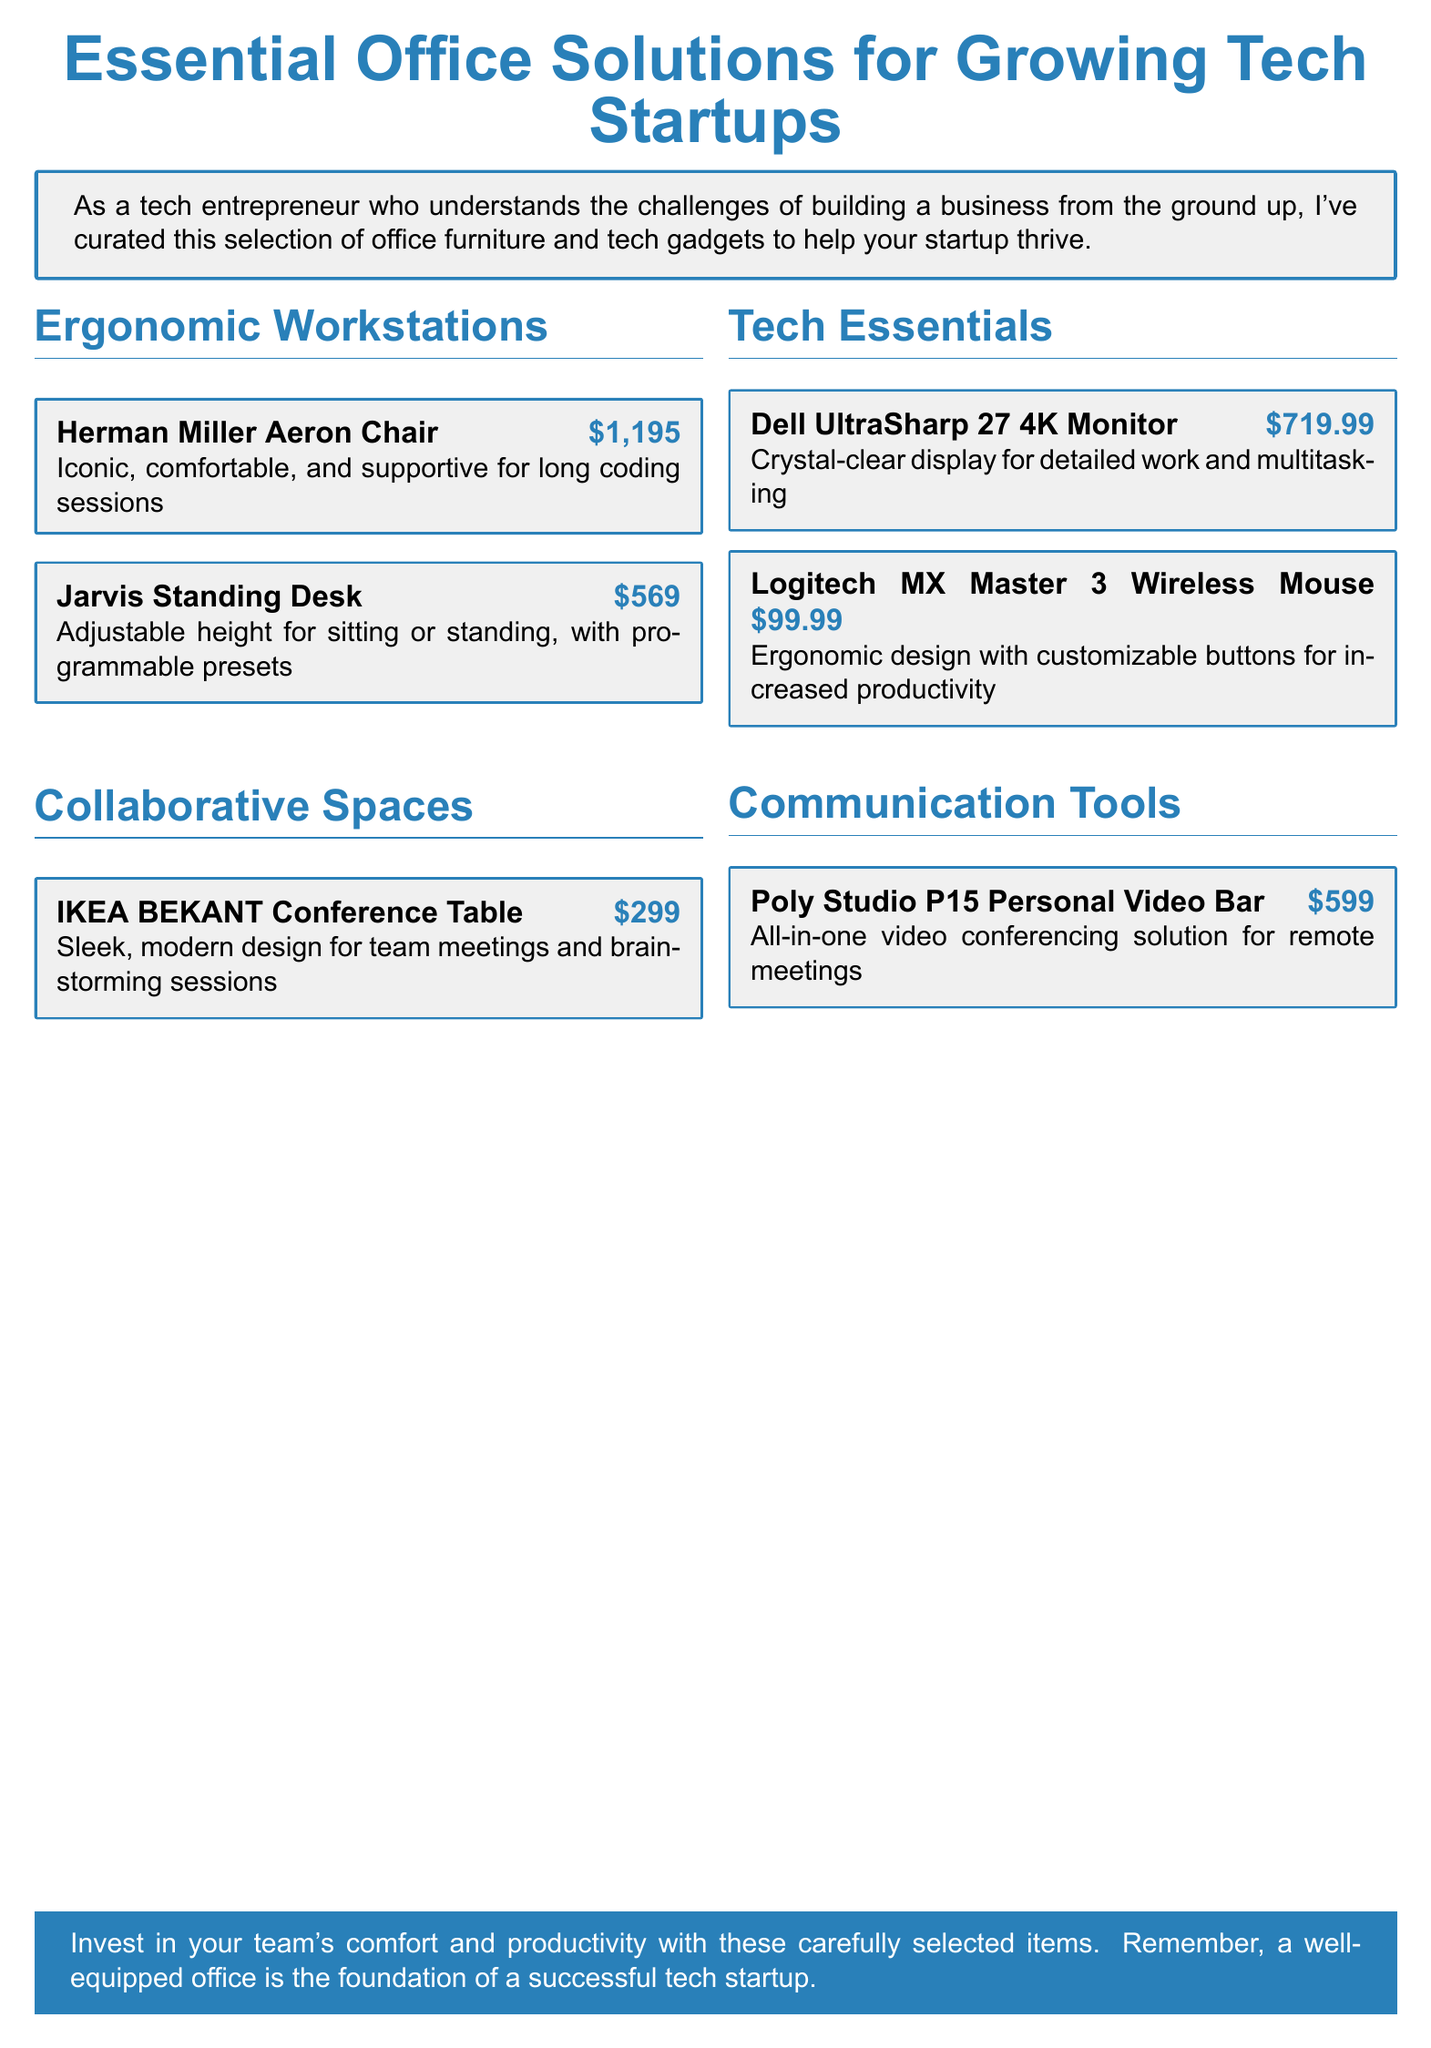What is the price of the Herman Miller Aeron Chair? The price is listed next to the chair in the document.
Answer: $1,195 How many collaborative spaces items are listed? The document lists the number of items under the section for collaborative spaces.
Answer: 1 What technology gadget is described as an all-in-one video conferencing solution? This item is specifically mentioned in the communication tools section of the document.
Answer: Poly Studio P15 Personal Video Bar Which monitor is featured in the tech essentials? The document names the specific monitor in the tech essentials category.
Answer: Dell UltraSharp 27 4K Monitor What feature does the Jarvis Standing Desk offer? The feature is described in the document under the ergonomic workstations section.
Answer: Adjustable height What is the total number of ergonomic workstations listed? This is determined by counting the items in the ergonomic workstations section.
Answer: 2 What color is primarily used for the document's headings? The color used for headings can be found in the styling of the text throughout the document.
Answer: Tech blue What is the purpose of the items listed in the catalog? The document explains the general aim of the selections made in the introduction paragraph.
Answer: To help your startup thrive What brand is the wireless mouse from? The document lists the specific brand alongside the product name in the tech essentials section.
Answer: Logitech 